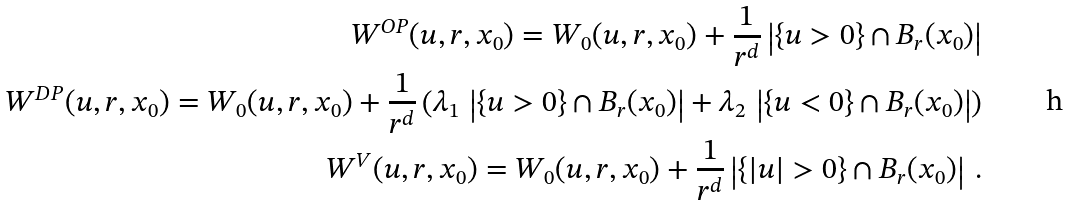Convert formula to latex. <formula><loc_0><loc_0><loc_500><loc_500>W ^ { O P } ( u , r , x _ { 0 } ) = W _ { 0 } ( u , r , x _ { 0 } ) + \frac { 1 } { r ^ { d } } \left | \{ u > 0 \} \cap B _ { r } ( x _ { 0 } ) \right | \\ W ^ { D P } ( u , r , x _ { 0 } ) = W _ { 0 } ( u , r , x _ { 0 } ) + \frac { 1 } { r ^ { d } } \left ( \lambda _ { 1 } \, \left | \{ u > 0 \} \cap B _ { r } ( x _ { 0 } ) \right | + \lambda _ { 2 } \, \left | \{ u < 0 \} \cap B _ { r } ( x _ { 0 } ) \right | \right ) \\ W ^ { V } ( u , r , x _ { 0 } ) = W _ { 0 } ( u , r , x _ { 0 } ) + \frac { 1 } { r ^ { d } } \left | \{ | u | > 0 \} \cap B _ { r } ( x _ { 0 } ) \right | \, .</formula> 